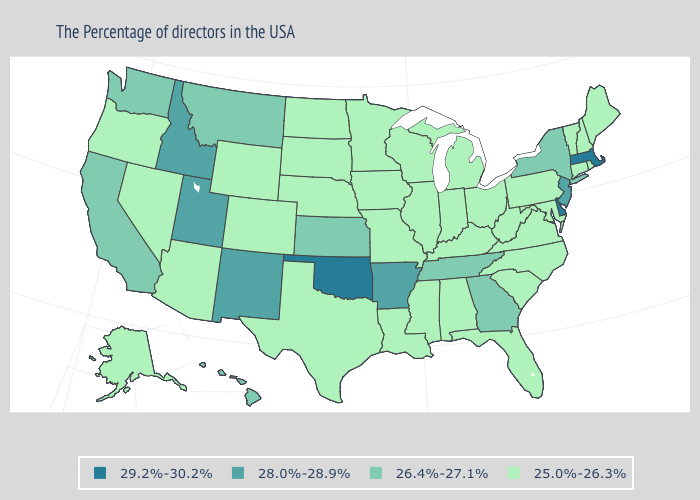Which states have the highest value in the USA?
Concise answer only. Massachusetts, Delaware, Oklahoma. Does Iowa have the lowest value in the USA?
Give a very brief answer. Yes. Among the states that border South Dakota , does Nebraska have the lowest value?
Be succinct. Yes. Does the map have missing data?
Give a very brief answer. No. What is the value of New York?
Keep it brief. 26.4%-27.1%. Does Pennsylvania have the lowest value in the Northeast?
Be succinct. Yes. What is the lowest value in the USA?
Write a very short answer. 25.0%-26.3%. Does Nebraska have a higher value than Iowa?
Keep it brief. No. Which states hav the highest value in the MidWest?
Keep it brief. Kansas. Name the states that have a value in the range 29.2%-30.2%?
Quick response, please. Massachusetts, Delaware, Oklahoma. Among the states that border Colorado , which have the highest value?
Short answer required. Oklahoma. Which states hav the highest value in the South?
Quick response, please. Delaware, Oklahoma. What is the highest value in states that border Rhode Island?
Write a very short answer. 29.2%-30.2%. What is the value of California?
Give a very brief answer. 26.4%-27.1%. What is the value of New York?
Quick response, please. 26.4%-27.1%. 